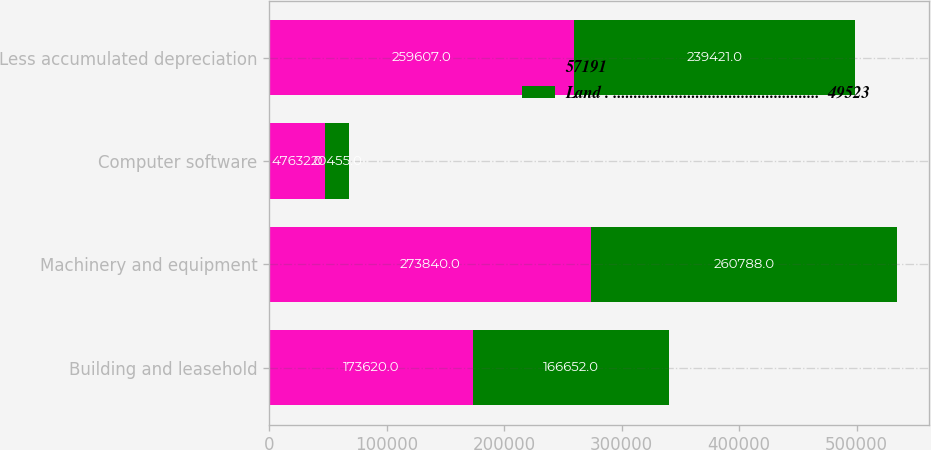<chart> <loc_0><loc_0><loc_500><loc_500><stacked_bar_chart><ecel><fcel>Building and leasehold<fcel>Machinery and equipment<fcel>Computer software<fcel>Less accumulated depreciation<nl><fcel>57191<fcel>173620<fcel>273840<fcel>47632<fcel>259607<nl><fcel>Land . ..................................................  49523<fcel>166652<fcel>260788<fcel>20455<fcel>239421<nl></chart> 